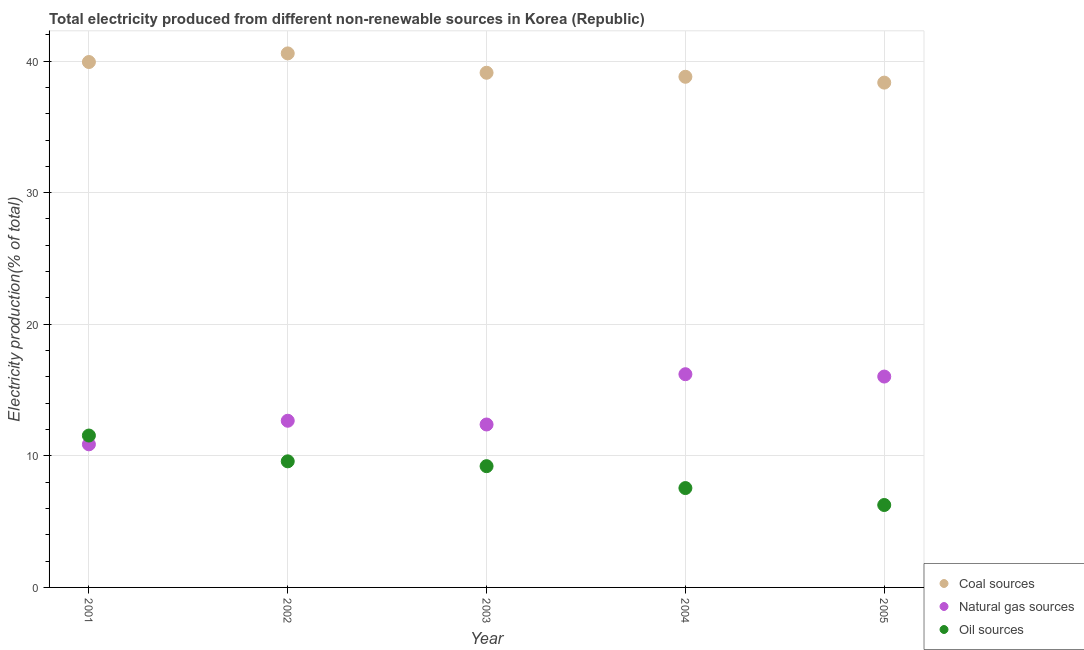How many different coloured dotlines are there?
Your answer should be very brief. 3. Is the number of dotlines equal to the number of legend labels?
Ensure brevity in your answer.  Yes. What is the percentage of electricity produced by oil sources in 2004?
Offer a terse response. 7.55. Across all years, what is the maximum percentage of electricity produced by coal?
Provide a short and direct response. 40.58. Across all years, what is the minimum percentage of electricity produced by coal?
Make the answer very short. 38.36. What is the total percentage of electricity produced by natural gas in the graph?
Make the answer very short. 68.15. What is the difference between the percentage of electricity produced by oil sources in 2003 and that in 2004?
Keep it short and to the point. 1.66. What is the difference between the percentage of electricity produced by oil sources in 2003 and the percentage of electricity produced by natural gas in 2005?
Your answer should be compact. -6.81. What is the average percentage of electricity produced by coal per year?
Provide a succinct answer. 39.36. In the year 2003, what is the difference between the percentage of electricity produced by coal and percentage of electricity produced by natural gas?
Give a very brief answer. 26.73. In how many years, is the percentage of electricity produced by oil sources greater than 36 %?
Provide a short and direct response. 0. What is the ratio of the percentage of electricity produced by natural gas in 2002 to that in 2004?
Give a very brief answer. 0.78. What is the difference between the highest and the second highest percentage of electricity produced by natural gas?
Offer a terse response. 0.18. What is the difference between the highest and the lowest percentage of electricity produced by coal?
Your response must be concise. 2.22. In how many years, is the percentage of electricity produced by natural gas greater than the average percentage of electricity produced by natural gas taken over all years?
Keep it short and to the point. 2. Is the sum of the percentage of electricity produced by natural gas in 2003 and 2005 greater than the maximum percentage of electricity produced by coal across all years?
Offer a terse response. No. Is the percentage of electricity produced by coal strictly less than the percentage of electricity produced by natural gas over the years?
Provide a succinct answer. No. How many years are there in the graph?
Provide a short and direct response. 5. What is the difference between two consecutive major ticks on the Y-axis?
Keep it short and to the point. 10. Are the values on the major ticks of Y-axis written in scientific E-notation?
Provide a short and direct response. No. Does the graph contain any zero values?
Offer a terse response. No. Where does the legend appear in the graph?
Your answer should be compact. Bottom right. How are the legend labels stacked?
Provide a short and direct response. Vertical. What is the title of the graph?
Make the answer very short. Total electricity produced from different non-renewable sources in Korea (Republic). What is the label or title of the X-axis?
Your answer should be compact. Year. What is the label or title of the Y-axis?
Ensure brevity in your answer.  Electricity production(% of total). What is the Electricity production(% of total) in Coal sources in 2001?
Offer a very short reply. 39.93. What is the Electricity production(% of total) of Natural gas sources in 2001?
Give a very brief answer. 10.87. What is the Electricity production(% of total) of Oil sources in 2001?
Provide a short and direct response. 11.54. What is the Electricity production(% of total) of Coal sources in 2002?
Offer a terse response. 40.58. What is the Electricity production(% of total) of Natural gas sources in 2002?
Give a very brief answer. 12.67. What is the Electricity production(% of total) of Oil sources in 2002?
Your response must be concise. 9.58. What is the Electricity production(% of total) of Coal sources in 2003?
Provide a succinct answer. 39.11. What is the Electricity production(% of total) of Natural gas sources in 2003?
Provide a short and direct response. 12.38. What is the Electricity production(% of total) of Oil sources in 2003?
Offer a terse response. 9.21. What is the Electricity production(% of total) in Coal sources in 2004?
Your answer should be very brief. 38.8. What is the Electricity production(% of total) of Natural gas sources in 2004?
Ensure brevity in your answer.  16.2. What is the Electricity production(% of total) of Oil sources in 2004?
Ensure brevity in your answer.  7.55. What is the Electricity production(% of total) in Coal sources in 2005?
Your answer should be compact. 38.36. What is the Electricity production(% of total) of Natural gas sources in 2005?
Provide a short and direct response. 16.02. What is the Electricity production(% of total) in Oil sources in 2005?
Provide a short and direct response. 6.26. Across all years, what is the maximum Electricity production(% of total) in Coal sources?
Give a very brief answer. 40.58. Across all years, what is the maximum Electricity production(% of total) in Natural gas sources?
Provide a succinct answer. 16.2. Across all years, what is the maximum Electricity production(% of total) of Oil sources?
Offer a very short reply. 11.54. Across all years, what is the minimum Electricity production(% of total) in Coal sources?
Keep it short and to the point. 38.36. Across all years, what is the minimum Electricity production(% of total) of Natural gas sources?
Make the answer very short. 10.87. Across all years, what is the minimum Electricity production(% of total) in Oil sources?
Offer a terse response. 6.26. What is the total Electricity production(% of total) of Coal sources in the graph?
Make the answer very short. 196.78. What is the total Electricity production(% of total) in Natural gas sources in the graph?
Ensure brevity in your answer.  68.15. What is the total Electricity production(% of total) in Oil sources in the graph?
Make the answer very short. 44.15. What is the difference between the Electricity production(% of total) of Coal sources in 2001 and that in 2002?
Offer a very short reply. -0.65. What is the difference between the Electricity production(% of total) in Natural gas sources in 2001 and that in 2002?
Give a very brief answer. -1.79. What is the difference between the Electricity production(% of total) in Oil sources in 2001 and that in 2002?
Your answer should be very brief. 1.96. What is the difference between the Electricity production(% of total) of Coal sources in 2001 and that in 2003?
Offer a very short reply. 0.82. What is the difference between the Electricity production(% of total) in Natural gas sources in 2001 and that in 2003?
Make the answer very short. -1.51. What is the difference between the Electricity production(% of total) in Oil sources in 2001 and that in 2003?
Give a very brief answer. 2.33. What is the difference between the Electricity production(% of total) of Coal sources in 2001 and that in 2004?
Offer a very short reply. 1.12. What is the difference between the Electricity production(% of total) in Natural gas sources in 2001 and that in 2004?
Ensure brevity in your answer.  -5.33. What is the difference between the Electricity production(% of total) in Oil sources in 2001 and that in 2004?
Your answer should be compact. 3.99. What is the difference between the Electricity production(% of total) in Coal sources in 2001 and that in 2005?
Keep it short and to the point. 1.57. What is the difference between the Electricity production(% of total) in Natural gas sources in 2001 and that in 2005?
Provide a short and direct response. -5.15. What is the difference between the Electricity production(% of total) of Oil sources in 2001 and that in 2005?
Offer a very short reply. 5.28. What is the difference between the Electricity production(% of total) in Coal sources in 2002 and that in 2003?
Your answer should be very brief. 1.47. What is the difference between the Electricity production(% of total) in Natural gas sources in 2002 and that in 2003?
Your response must be concise. 0.28. What is the difference between the Electricity production(% of total) in Oil sources in 2002 and that in 2003?
Your answer should be compact. 0.37. What is the difference between the Electricity production(% of total) in Coal sources in 2002 and that in 2004?
Ensure brevity in your answer.  1.78. What is the difference between the Electricity production(% of total) in Natural gas sources in 2002 and that in 2004?
Your response must be concise. -3.54. What is the difference between the Electricity production(% of total) in Oil sources in 2002 and that in 2004?
Your answer should be very brief. 2.03. What is the difference between the Electricity production(% of total) in Coal sources in 2002 and that in 2005?
Offer a very short reply. 2.22. What is the difference between the Electricity production(% of total) of Natural gas sources in 2002 and that in 2005?
Ensure brevity in your answer.  -3.36. What is the difference between the Electricity production(% of total) of Oil sources in 2002 and that in 2005?
Your response must be concise. 3.32. What is the difference between the Electricity production(% of total) of Coal sources in 2003 and that in 2004?
Your response must be concise. 0.31. What is the difference between the Electricity production(% of total) in Natural gas sources in 2003 and that in 2004?
Offer a very short reply. -3.82. What is the difference between the Electricity production(% of total) in Oil sources in 2003 and that in 2004?
Give a very brief answer. 1.66. What is the difference between the Electricity production(% of total) in Coal sources in 2003 and that in 2005?
Provide a short and direct response. 0.75. What is the difference between the Electricity production(% of total) of Natural gas sources in 2003 and that in 2005?
Ensure brevity in your answer.  -3.64. What is the difference between the Electricity production(% of total) of Oil sources in 2003 and that in 2005?
Offer a terse response. 2.95. What is the difference between the Electricity production(% of total) of Coal sources in 2004 and that in 2005?
Offer a terse response. 0.44. What is the difference between the Electricity production(% of total) in Natural gas sources in 2004 and that in 2005?
Provide a succinct answer. 0.18. What is the difference between the Electricity production(% of total) of Oil sources in 2004 and that in 2005?
Offer a terse response. 1.29. What is the difference between the Electricity production(% of total) of Coal sources in 2001 and the Electricity production(% of total) of Natural gas sources in 2002?
Offer a very short reply. 27.26. What is the difference between the Electricity production(% of total) of Coal sources in 2001 and the Electricity production(% of total) of Oil sources in 2002?
Give a very brief answer. 30.34. What is the difference between the Electricity production(% of total) of Natural gas sources in 2001 and the Electricity production(% of total) of Oil sources in 2002?
Your response must be concise. 1.29. What is the difference between the Electricity production(% of total) of Coal sources in 2001 and the Electricity production(% of total) of Natural gas sources in 2003?
Your response must be concise. 27.54. What is the difference between the Electricity production(% of total) in Coal sources in 2001 and the Electricity production(% of total) in Oil sources in 2003?
Your response must be concise. 30.71. What is the difference between the Electricity production(% of total) of Natural gas sources in 2001 and the Electricity production(% of total) of Oil sources in 2003?
Your response must be concise. 1.66. What is the difference between the Electricity production(% of total) of Coal sources in 2001 and the Electricity production(% of total) of Natural gas sources in 2004?
Make the answer very short. 23.72. What is the difference between the Electricity production(% of total) in Coal sources in 2001 and the Electricity production(% of total) in Oil sources in 2004?
Ensure brevity in your answer.  32.38. What is the difference between the Electricity production(% of total) of Natural gas sources in 2001 and the Electricity production(% of total) of Oil sources in 2004?
Keep it short and to the point. 3.32. What is the difference between the Electricity production(% of total) in Coal sources in 2001 and the Electricity production(% of total) in Natural gas sources in 2005?
Provide a short and direct response. 23.9. What is the difference between the Electricity production(% of total) in Coal sources in 2001 and the Electricity production(% of total) in Oil sources in 2005?
Offer a very short reply. 33.66. What is the difference between the Electricity production(% of total) in Natural gas sources in 2001 and the Electricity production(% of total) in Oil sources in 2005?
Your answer should be compact. 4.61. What is the difference between the Electricity production(% of total) in Coal sources in 2002 and the Electricity production(% of total) in Natural gas sources in 2003?
Provide a succinct answer. 28.2. What is the difference between the Electricity production(% of total) of Coal sources in 2002 and the Electricity production(% of total) of Oil sources in 2003?
Provide a short and direct response. 31.37. What is the difference between the Electricity production(% of total) of Natural gas sources in 2002 and the Electricity production(% of total) of Oil sources in 2003?
Your response must be concise. 3.45. What is the difference between the Electricity production(% of total) in Coal sources in 2002 and the Electricity production(% of total) in Natural gas sources in 2004?
Your answer should be compact. 24.38. What is the difference between the Electricity production(% of total) in Coal sources in 2002 and the Electricity production(% of total) in Oil sources in 2004?
Make the answer very short. 33.03. What is the difference between the Electricity production(% of total) in Natural gas sources in 2002 and the Electricity production(% of total) in Oil sources in 2004?
Provide a succinct answer. 5.12. What is the difference between the Electricity production(% of total) of Coal sources in 2002 and the Electricity production(% of total) of Natural gas sources in 2005?
Provide a short and direct response. 24.56. What is the difference between the Electricity production(% of total) in Coal sources in 2002 and the Electricity production(% of total) in Oil sources in 2005?
Provide a short and direct response. 34.32. What is the difference between the Electricity production(% of total) in Natural gas sources in 2002 and the Electricity production(% of total) in Oil sources in 2005?
Ensure brevity in your answer.  6.4. What is the difference between the Electricity production(% of total) in Coal sources in 2003 and the Electricity production(% of total) in Natural gas sources in 2004?
Your answer should be compact. 22.91. What is the difference between the Electricity production(% of total) of Coal sources in 2003 and the Electricity production(% of total) of Oil sources in 2004?
Provide a short and direct response. 31.56. What is the difference between the Electricity production(% of total) of Natural gas sources in 2003 and the Electricity production(% of total) of Oil sources in 2004?
Make the answer very short. 4.83. What is the difference between the Electricity production(% of total) of Coal sources in 2003 and the Electricity production(% of total) of Natural gas sources in 2005?
Your answer should be compact. 23.09. What is the difference between the Electricity production(% of total) in Coal sources in 2003 and the Electricity production(% of total) in Oil sources in 2005?
Provide a short and direct response. 32.85. What is the difference between the Electricity production(% of total) of Natural gas sources in 2003 and the Electricity production(% of total) of Oil sources in 2005?
Ensure brevity in your answer.  6.12. What is the difference between the Electricity production(% of total) in Coal sources in 2004 and the Electricity production(% of total) in Natural gas sources in 2005?
Your answer should be compact. 22.78. What is the difference between the Electricity production(% of total) of Coal sources in 2004 and the Electricity production(% of total) of Oil sources in 2005?
Provide a succinct answer. 32.54. What is the difference between the Electricity production(% of total) of Natural gas sources in 2004 and the Electricity production(% of total) of Oil sources in 2005?
Offer a terse response. 9.94. What is the average Electricity production(% of total) in Coal sources per year?
Give a very brief answer. 39.36. What is the average Electricity production(% of total) of Natural gas sources per year?
Provide a succinct answer. 13.63. What is the average Electricity production(% of total) in Oil sources per year?
Offer a terse response. 8.83. In the year 2001, what is the difference between the Electricity production(% of total) in Coal sources and Electricity production(% of total) in Natural gas sources?
Your response must be concise. 29.05. In the year 2001, what is the difference between the Electricity production(% of total) in Coal sources and Electricity production(% of total) in Oil sources?
Provide a succinct answer. 28.38. In the year 2001, what is the difference between the Electricity production(% of total) of Natural gas sources and Electricity production(% of total) of Oil sources?
Offer a terse response. -0.67. In the year 2002, what is the difference between the Electricity production(% of total) in Coal sources and Electricity production(% of total) in Natural gas sources?
Your answer should be very brief. 27.91. In the year 2002, what is the difference between the Electricity production(% of total) of Coal sources and Electricity production(% of total) of Oil sources?
Ensure brevity in your answer.  31. In the year 2002, what is the difference between the Electricity production(% of total) in Natural gas sources and Electricity production(% of total) in Oil sources?
Offer a terse response. 3.08. In the year 2003, what is the difference between the Electricity production(% of total) in Coal sources and Electricity production(% of total) in Natural gas sources?
Keep it short and to the point. 26.73. In the year 2003, what is the difference between the Electricity production(% of total) in Coal sources and Electricity production(% of total) in Oil sources?
Your answer should be compact. 29.9. In the year 2003, what is the difference between the Electricity production(% of total) in Natural gas sources and Electricity production(% of total) in Oil sources?
Keep it short and to the point. 3.17. In the year 2004, what is the difference between the Electricity production(% of total) of Coal sources and Electricity production(% of total) of Natural gas sources?
Offer a terse response. 22.6. In the year 2004, what is the difference between the Electricity production(% of total) of Coal sources and Electricity production(% of total) of Oil sources?
Provide a short and direct response. 31.25. In the year 2004, what is the difference between the Electricity production(% of total) of Natural gas sources and Electricity production(% of total) of Oil sources?
Your answer should be very brief. 8.65. In the year 2005, what is the difference between the Electricity production(% of total) in Coal sources and Electricity production(% of total) in Natural gas sources?
Keep it short and to the point. 22.34. In the year 2005, what is the difference between the Electricity production(% of total) in Coal sources and Electricity production(% of total) in Oil sources?
Keep it short and to the point. 32.1. In the year 2005, what is the difference between the Electricity production(% of total) of Natural gas sources and Electricity production(% of total) of Oil sources?
Your response must be concise. 9.76. What is the ratio of the Electricity production(% of total) in Coal sources in 2001 to that in 2002?
Your answer should be compact. 0.98. What is the ratio of the Electricity production(% of total) in Natural gas sources in 2001 to that in 2002?
Offer a very short reply. 0.86. What is the ratio of the Electricity production(% of total) in Oil sources in 2001 to that in 2002?
Offer a very short reply. 1.2. What is the ratio of the Electricity production(% of total) of Coal sources in 2001 to that in 2003?
Your response must be concise. 1.02. What is the ratio of the Electricity production(% of total) of Natural gas sources in 2001 to that in 2003?
Offer a terse response. 0.88. What is the ratio of the Electricity production(% of total) of Oil sources in 2001 to that in 2003?
Ensure brevity in your answer.  1.25. What is the ratio of the Electricity production(% of total) of Coal sources in 2001 to that in 2004?
Keep it short and to the point. 1.03. What is the ratio of the Electricity production(% of total) of Natural gas sources in 2001 to that in 2004?
Your response must be concise. 0.67. What is the ratio of the Electricity production(% of total) in Oil sources in 2001 to that in 2004?
Offer a very short reply. 1.53. What is the ratio of the Electricity production(% of total) of Coal sources in 2001 to that in 2005?
Give a very brief answer. 1.04. What is the ratio of the Electricity production(% of total) of Natural gas sources in 2001 to that in 2005?
Provide a short and direct response. 0.68. What is the ratio of the Electricity production(% of total) of Oil sources in 2001 to that in 2005?
Your answer should be very brief. 1.84. What is the ratio of the Electricity production(% of total) in Coal sources in 2002 to that in 2003?
Provide a short and direct response. 1.04. What is the ratio of the Electricity production(% of total) in Natural gas sources in 2002 to that in 2003?
Your answer should be very brief. 1.02. What is the ratio of the Electricity production(% of total) of Oil sources in 2002 to that in 2003?
Provide a short and direct response. 1.04. What is the ratio of the Electricity production(% of total) in Coal sources in 2002 to that in 2004?
Offer a very short reply. 1.05. What is the ratio of the Electricity production(% of total) in Natural gas sources in 2002 to that in 2004?
Give a very brief answer. 0.78. What is the ratio of the Electricity production(% of total) in Oil sources in 2002 to that in 2004?
Ensure brevity in your answer.  1.27. What is the ratio of the Electricity production(% of total) in Coal sources in 2002 to that in 2005?
Provide a succinct answer. 1.06. What is the ratio of the Electricity production(% of total) of Natural gas sources in 2002 to that in 2005?
Offer a very short reply. 0.79. What is the ratio of the Electricity production(% of total) of Oil sources in 2002 to that in 2005?
Your answer should be very brief. 1.53. What is the ratio of the Electricity production(% of total) in Coal sources in 2003 to that in 2004?
Give a very brief answer. 1.01. What is the ratio of the Electricity production(% of total) of Natural gas sources in 2003 to that in 2004?
Offer a very short reply. 0.76. What is the ratio of the Electricity production(% of total) of Oil sources in 2003 to that in 2004?
Your response must be concise. 1.22. What is the ratio of the Electricity production(% of total) in Coal sources in 2003 to that in 2005?
Make the answer very short. 1.02. What is the ratio of the Electricity production(% of total) in Natural gas sources in 2003 to that in 2005?
Offer a terse response. 0.77. What is the ratio of the Electricity production(% of total) in Oil sources in 2003 to that in 2005?
Keep it short and to the point. 1.47. What is the ratio of the Electricity production(% of total) of Coal sources in 2004 to that in 2005?
Ensure brevity in your answer.  1.01. What is the ratio of the Electricity production(% of total) in Natural gas sources in 2004 to that in 2005?
Keep it short and to the point. 1.01. What is the ratio of the Electricity production(% of total) in Oil sources in 2004 to that in 2005?
Your response must be concise. 1.21. What is the difference between the highest and the second highest Electricity production(% of total) in Coal sources?
Your answer should be very brief. 0.65. What is the difference between the highest and the second highest Electricity production(% of total) of Natural gas sources?
Give a very brief answer. 0.18. What is the difference between the highest and the second highest Electricity production(% of total) in Oil sources?
Provide a short and direct response. 1.96. What is the difference between the highest and the lowest Electricity production(% of total) of Coal sources?
Your response must be concise. 2.22. What is the difference between the highest and the lowest Electricity production(% of total) in Natural gas sources?
Make the answer very short. 5.33. What is the difference between the highest and the lowest Electricity production(% of total) of Oil sources?
Ensure brevity in your answer.  5.28. 